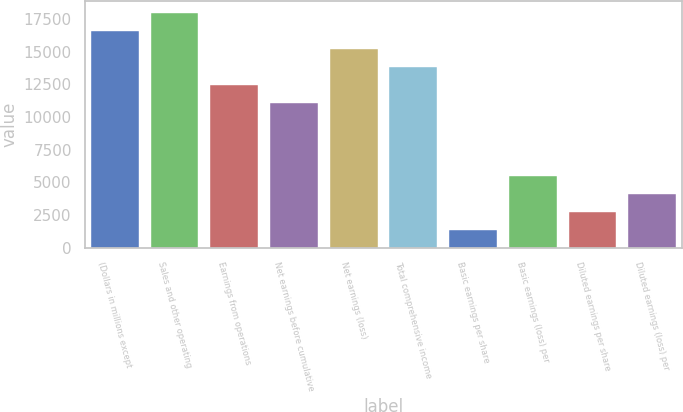<chart> <loc_0><loc_0><loc_500><loc_500><bar_chart><fcel>(Dollars in millions except<fcel>Sales and other operating<fcel>Earnings from operations<fcel>Net earnings before cumulative<fcel>Net earnings (loss)<fcel>Total comprehensive income<fcel>Basic earnings per share<fcel>Basic earnings (loss) per<fcel>Diluted earnings per share<fcel>Diluted earnings (loss) per<nl><fcel>16585.1<fcel>17967.2<fcel>12438.9<fcel>11056.8<fcel>15203<fcel>13821<fcel>1382.25<fcel>5528.49<fcel>2764.33<fcel>4146.41<nl></chart> 